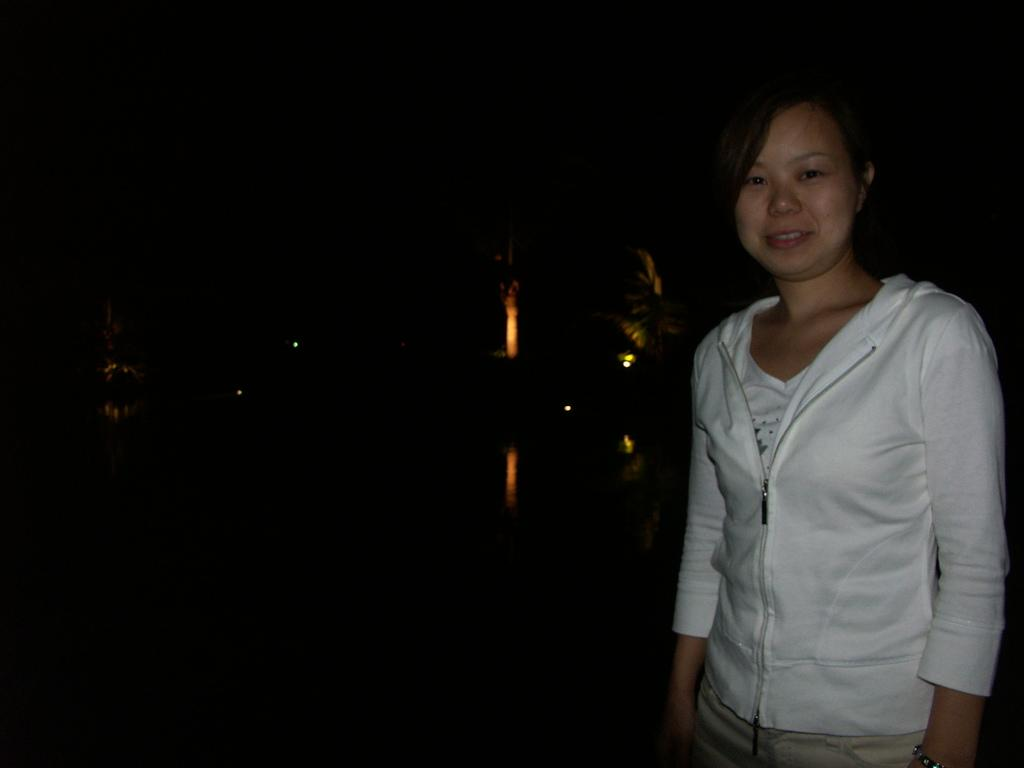What is the main subject of the image? There is a woman standing in the center of the image. What is the woman's expression in the image? The woman is smiling in the image. What can be seen in the background of the image? There are lights visible in the background of the image. What type of love is the woman expressing with her nose in the image? There is no indication of love or any specific expression involving the nose in the image. 